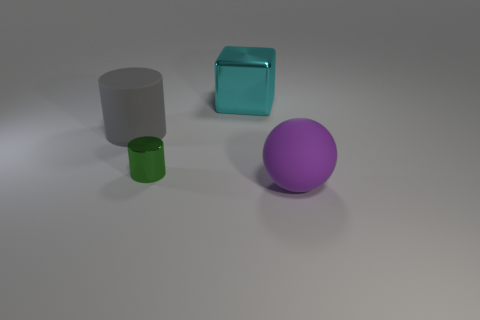There is a rubber thing behind the big thing that is in front of the matte cylinder; what size is it?
Provide a short and direct response. Large. Are there the same number of large blocks that are to the right of the big purple rubber object and cyan blocks that are in front of the large metal thing?
Ensure brevity in your answer.  Yes. Is there anything else that is the same size as the purple rubber ball?
Offer a terse response. Yes. There is a large thing that is the same material as the large gray cylinder; what color is it?
Your answer should be compact. Purple. Do the purple object and the large thing behind the gray object have the same material?
Your response must be concise. No. The big thing that is on the right side of the big gray rubber cylinder and in front of the cyan cube is what color?
Your response must be concise. Purple. How many cylinders are either big cyan shiny things or big gray objects?
Provide a succinct answer. 1. Is the shape of the cyan thing the same as the big rubber thing on the left side of the small thing?
Give a very brief answer. No. There is a thing that is both in front of the gray cylinder and behind the large purple object; what is its size?
Provide a short and direct response. Small. What is the shape of the big metallic object?
Ensure brevity in your answer.  Cube. 